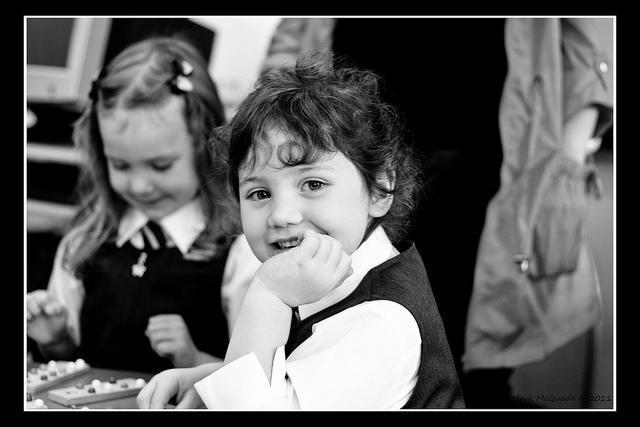How many people are there?
Give a very brief answer. 3. How many white trucks can you see?
Give a very brief answer. 0. 